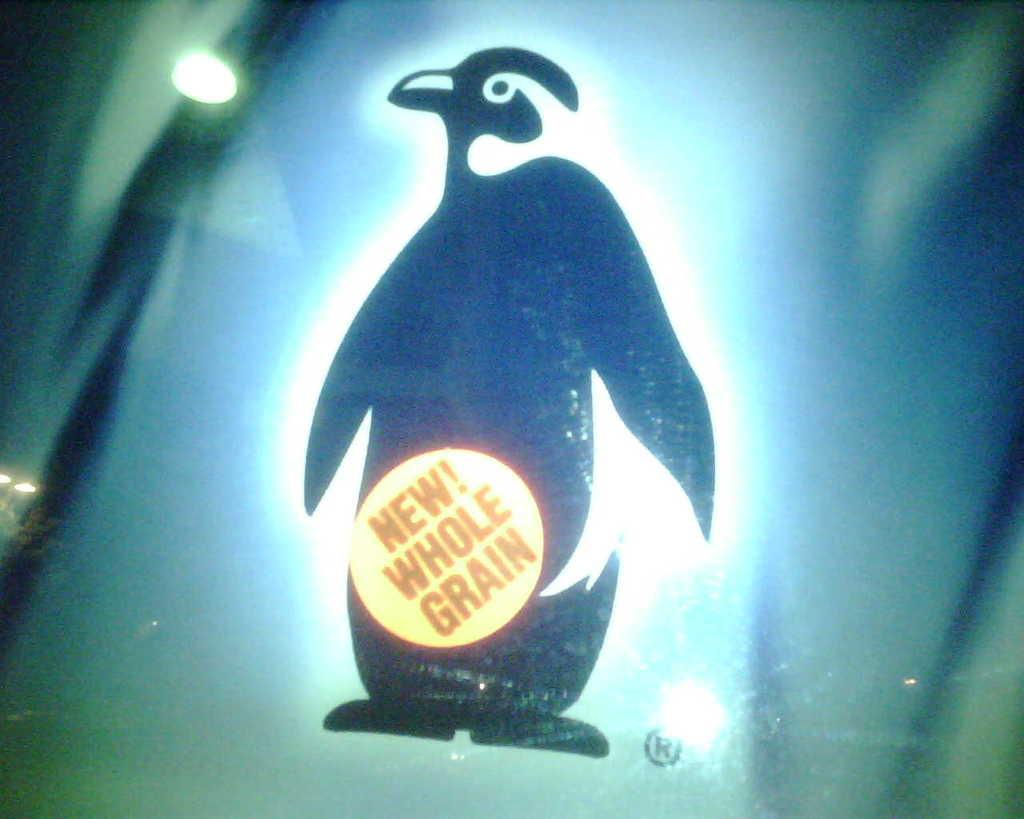What object is present in the image that can hold a liquid? There is a glass in the image. What is depicted on the glass? There is a picture of a penguin on the glass. Are there any words or letters on the glass? Yes, there is text on the glass. What can be seen reflecting off the surface of the glass? The reflection of a light is visible on the glass. What type of mitten is being used to increase profit in the image? There is no mitten or reference to profit in the image; it features a glass with a penguin picture and text. 